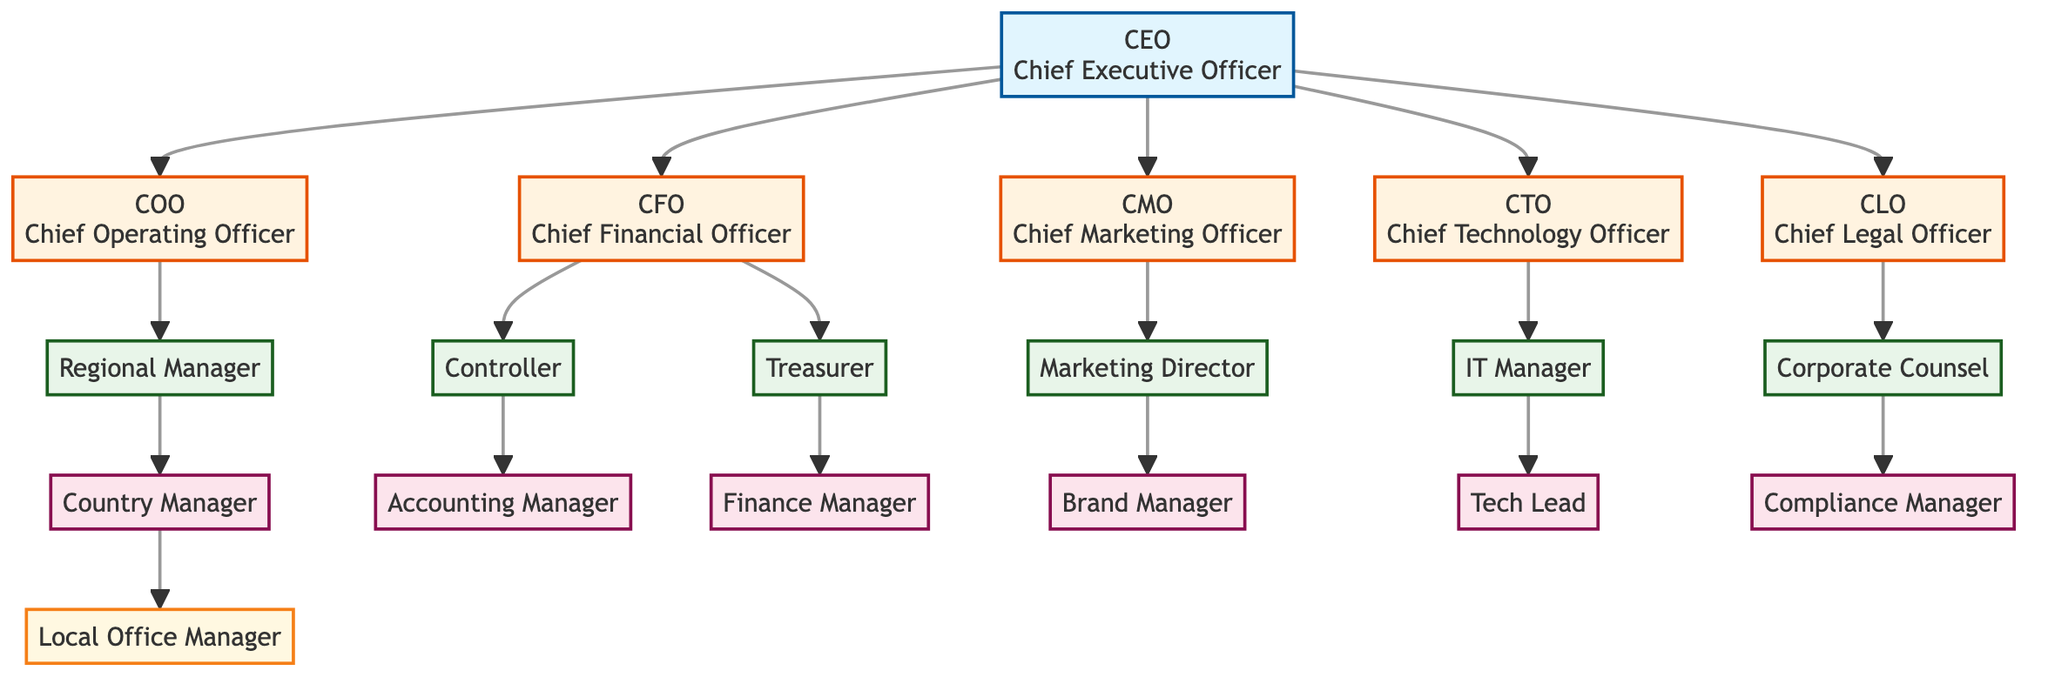What is the top position in the organizational structure? The diagram shows that the top position is labeled as CEO, which stands for Chief Executive Officer. It is placed at the highest level in the hierarchy, indicating its primary role in decision-making.
Answer: CEO How many direct reports does the CEO have? The diagram indicates that the CEO has five direct reports: COO, CFO, CMO, CTO, and CLO. Each of these positions is connected directly to the CEO, showcasing their direct relationship.
Answer: 5 Who reports directly to the CFO? According to the diagram, the positions that report directly to the CFO are the Controller and the Treasurer. This means both roles have a direct line of authority from the CFO.
Answer: Controller, Treasurer What is the lowest level of management depicted in the diagram? The diagram displays the Local Office Manager as the lowest level of management, which is positioned at the bottom of the hierarchy under the Country Manager, indicating it has the least authority in the organizational structure.
Answer: Local Office Manager Which officer oversees marketing activities? The Chief Marketing Officer (CMO) is responsible for overseeing marketing activities as indicated by its central role in the diagram, linking directly to the Marketing Director and further down to the Brand Manager.
Answer: CMO Which department does the IT Manager belong to? The IT Manager belongs to the Technology department, as shown in the diagram by the connection from the CTO (Chief Technology Officer) to the IT Manager, illustrating its position within that branch of the organization.
Answer: Technology How many layers of management are structured under the COO? The COO has three layers of management structured under it: the Regional Manager, who has the Country Manager, and then the Local Office Manager at the lowest layer. Thus, there are three layers in total.
Answer: 3 What is the role directly beneath the Corporate Counsel? The role directly beneath the Corporate Counsel, according to the diagram, is the Compliance Manager. This relationship shows the flow of authority within the legal department.
Answer: Compliance Manager Which position has the responsibility for financial oversight under the CFO? The Controller has the responsibility for financial oversight under the CFO, as depicted in the diagram where the Controller is directly linked to the CFO, indicating its role in managing the company's finances.
Answer: Controller 